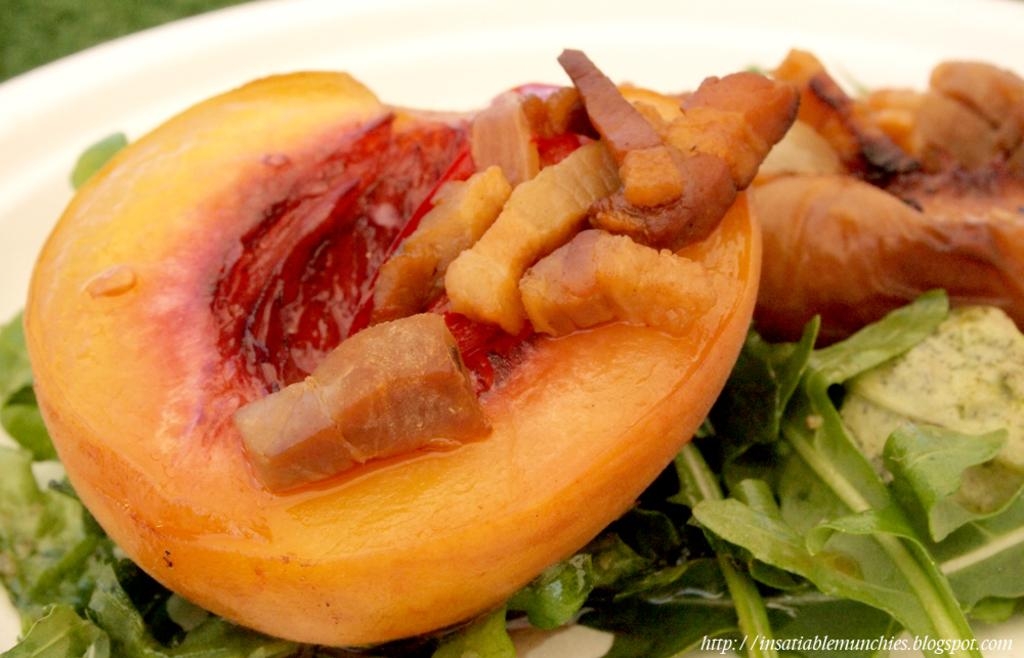What is on the plate that is visible in the image? There is food on a plate in the image. Besides the plate of food, what else can be seen in the image? There is some text visible at the bottom of the image. How many clocks are visible on the side of the plate in the image? There are no clocks visible in the image, as the focus is on the plate of food and the text at the bottom. 